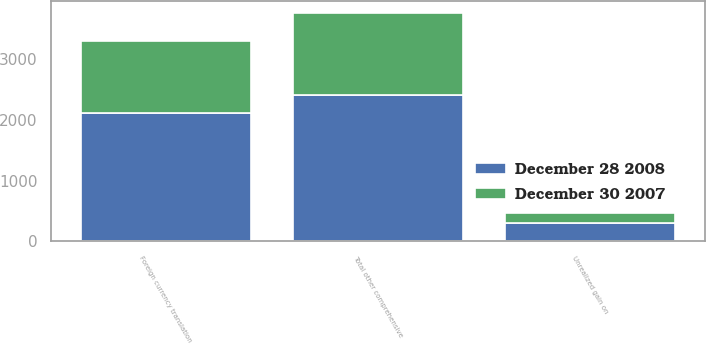<chart> <loc_0><loc_0><loc_500><loc_500><stacked_bar_chart><ecel><fcel>Foreign currency translation<fcel>Unrealized gain on<fcel>Total other comprehensive<nl><fcel>December 28 2008<fcel>2103<fcel>303<fcel>2406<nl><fcel>December 30 2007<fcel>1183<fcel>164<fcel>1347<nl></chart> 